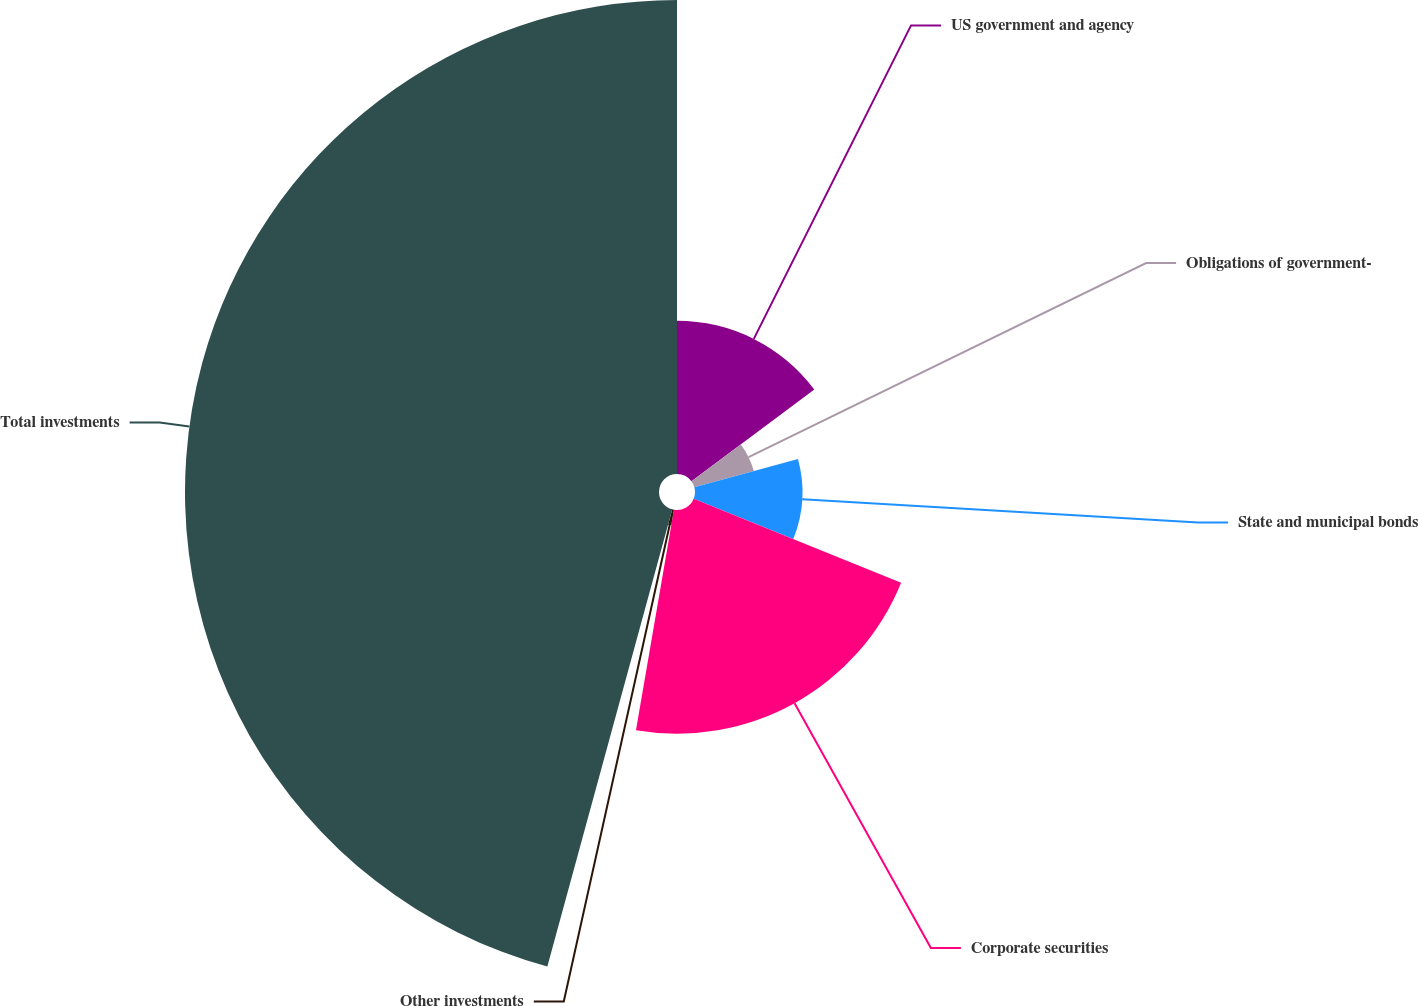<chart> <loc_0><loc_0><loc_500><loc_500><pie_chart><fcel>US government and agency<fcel>Obligations of government-<fcel>State and municipal bonds<fcel>Corporate securities<fcel>Other investments<fcel>Total investments<nl><fcel>14.8%<fcel>5.95%<fcel>10.37%<fcel>21.6%<fcel>1.53%<fcel>45.76%<nl></chart> 